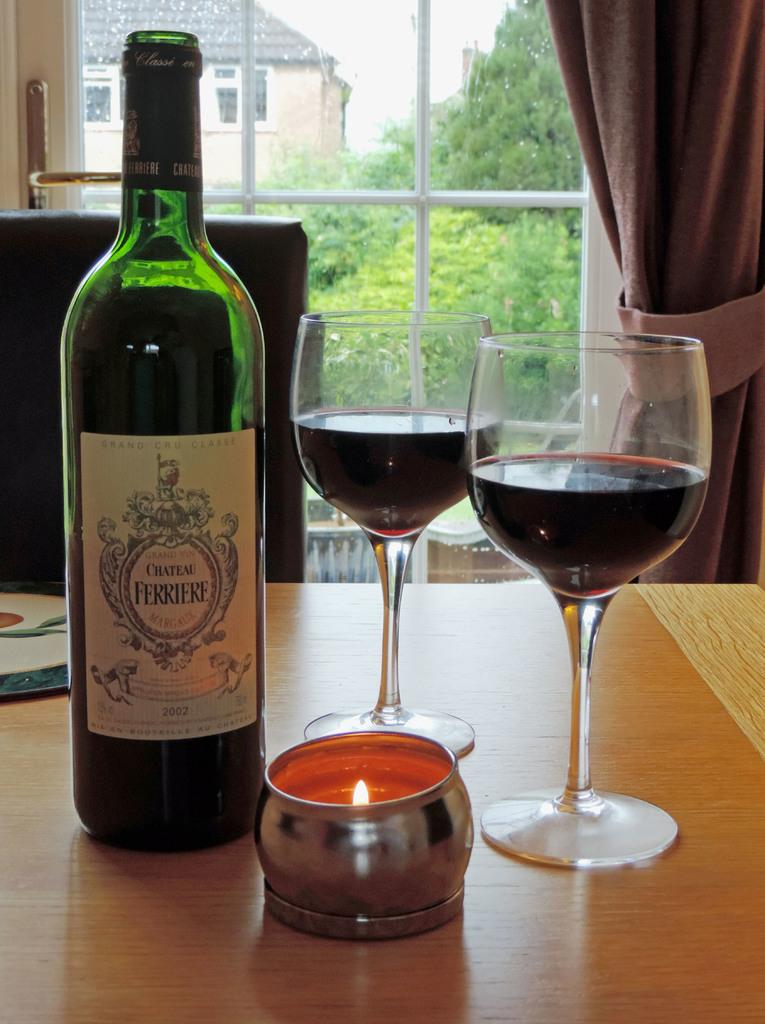<image>
Render a clear and concise summary of the photo. A candle, two glasses of wine and a bottle with a label saying "Chateau Ferriere" 